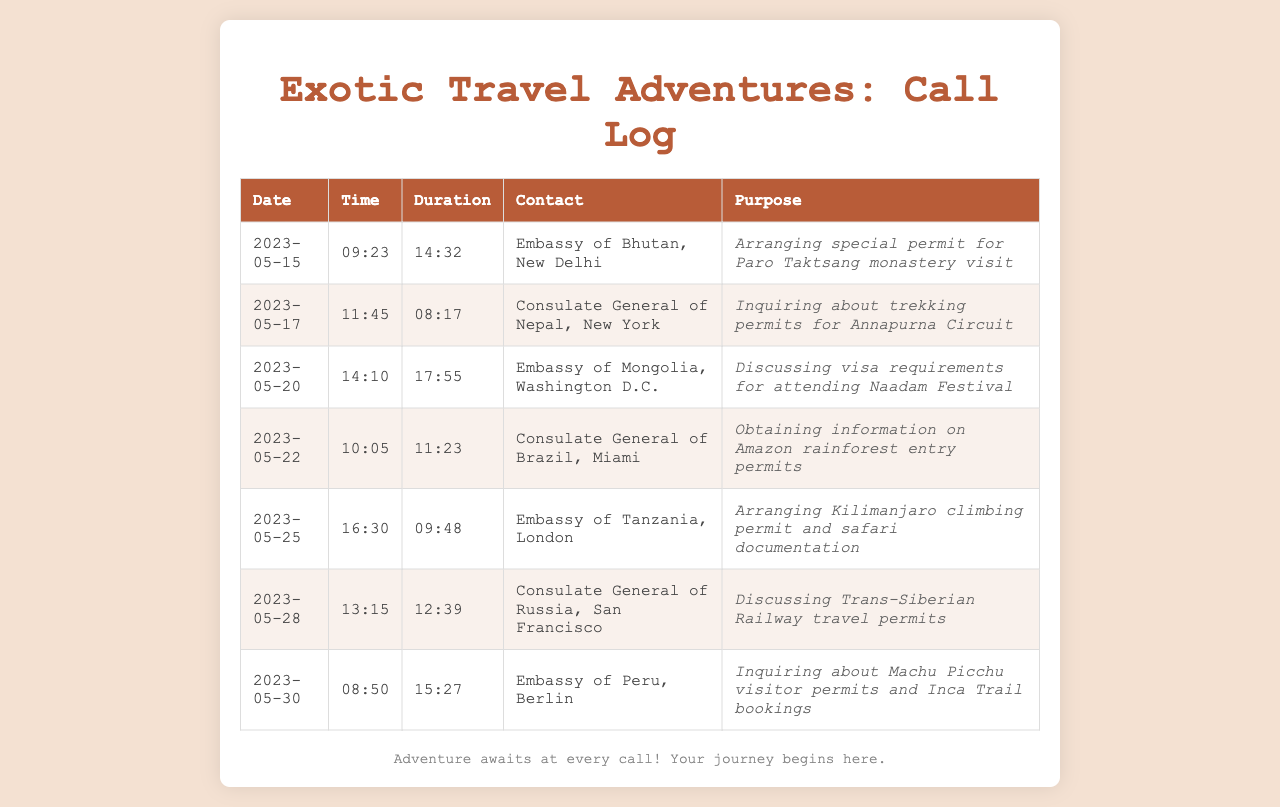What is the first call date recorded? The first call date in the log is the earliest date listed in the document. It is 2023-05-15.
Answer: 2023-05-15 Who did the last call go to? The last call listed in the document is directed to the Embassy of Peru in Berlin.
Answer: Embassy of Peru, Berlin What was the duration of the call to the Consulate General of Nepal? The duration of the call is specified in the document alongside the contact. For the Consulate General of Nepal, it is 08:17.
Answer: 08:17 What is the primary purpose of the call to the Embassy of Tanzania? The purpose of the call is stated in the document as arranging a climbing permit and safari documentation.
Answer: Arranging Kilimanjaro climbing permit and safari documentation How many calls were made to embassies regarding travel permits? By counting the calls related to travel permits from the document, there are five entries specifically discussing permits.
Answer: 5 What is the duration of the call made on May 20? The duration can be found in the row corresponding to May 20, which states 17:55.
Answer: 17:55 Which consulate was contacted for information about the Amazon rainforest? The document lists the Consulate General of Brazil in Miami as the contact for this inquiry.
Answer: Consulate General of Brazil, Miami What type of visa was discussed with the Embassy of Mongolia? The purpose of the call mentions discussing visa requirements for a specific event mentioned in the document.
Answer: Naadam Festival 